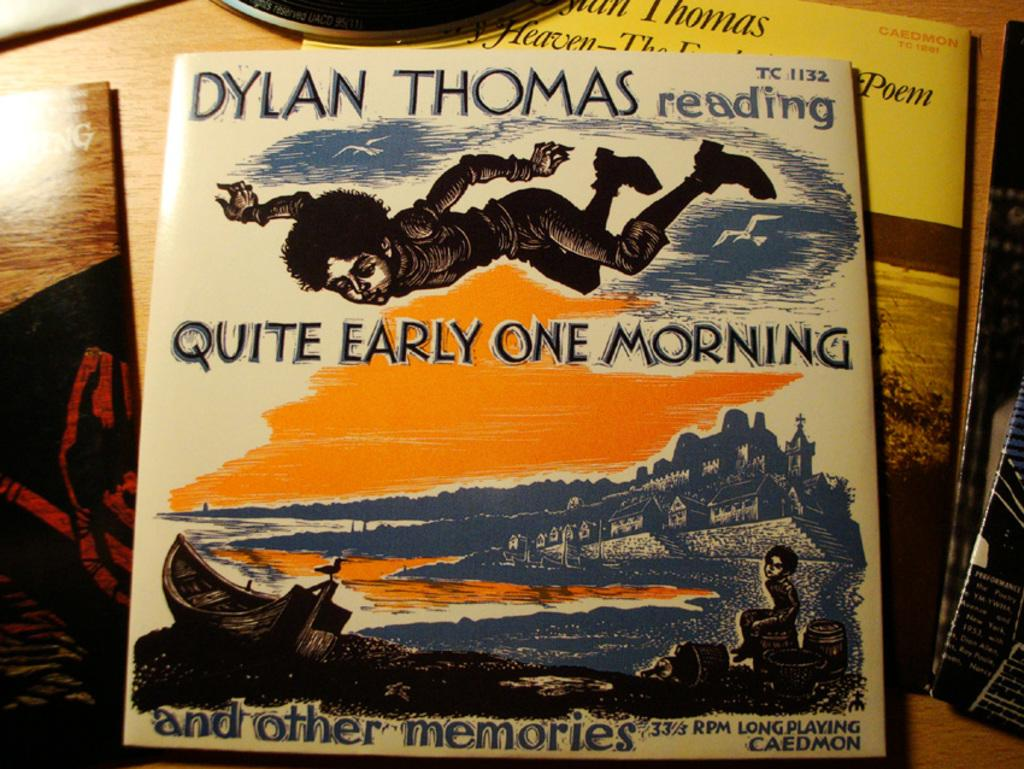Provide a one-sentence caption for the provided image. Poetry books are read on records by Dylan Thomas. 